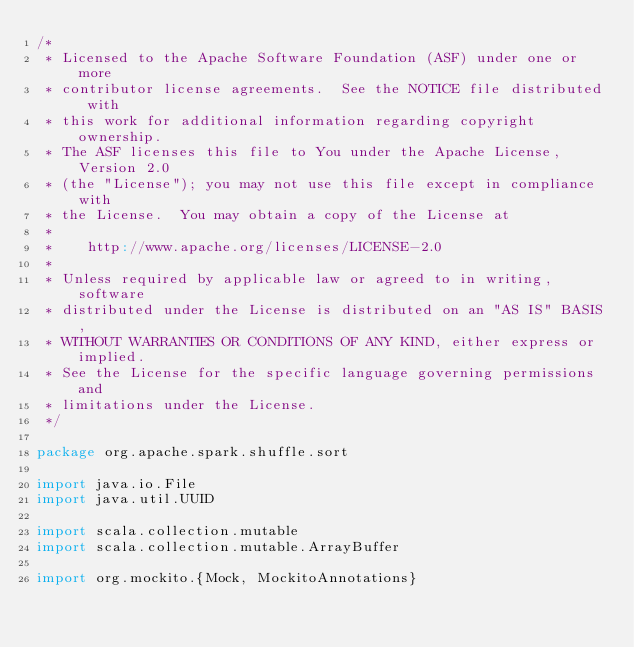<code> <loc_0><loc_0><loc_500><loc_500><_Scala_>/*
 * Licensed to the Apache Software Foundation (ASF) under one or more
 * contributor license agreements.  See the NOTICE file distributed with
 * this work for additional information regarding copyright ownership.
 * The ASF licenses this file to You under the Apache License, Version 2.0
 * (the "License"); you may not use this file except in compliance with
 * the License.  You may obtain a copy of the License at
 *
 *    http://www.apache.org/licenses/LICENSE-2.0
 *
 * Unless required by applicable law or agreed to in writing, software
 * distributed under the License is distributed on an "AS IS" BASIS,
 * WITHOUT WARRANTIES OR CONDITIONS OF ANY KIND, either express or implied.
 * See the License for the specific language governing permissions and
 * limitations under the License.
 */

package org.apache.spark.shuffle.sort

import java.io.File
import java.util.UUID

import scala.collection.mutable
import scala.collection.mutable.ArrayBuffer

import org.mockito.{Mock, MockitoAnnotations}</code> 